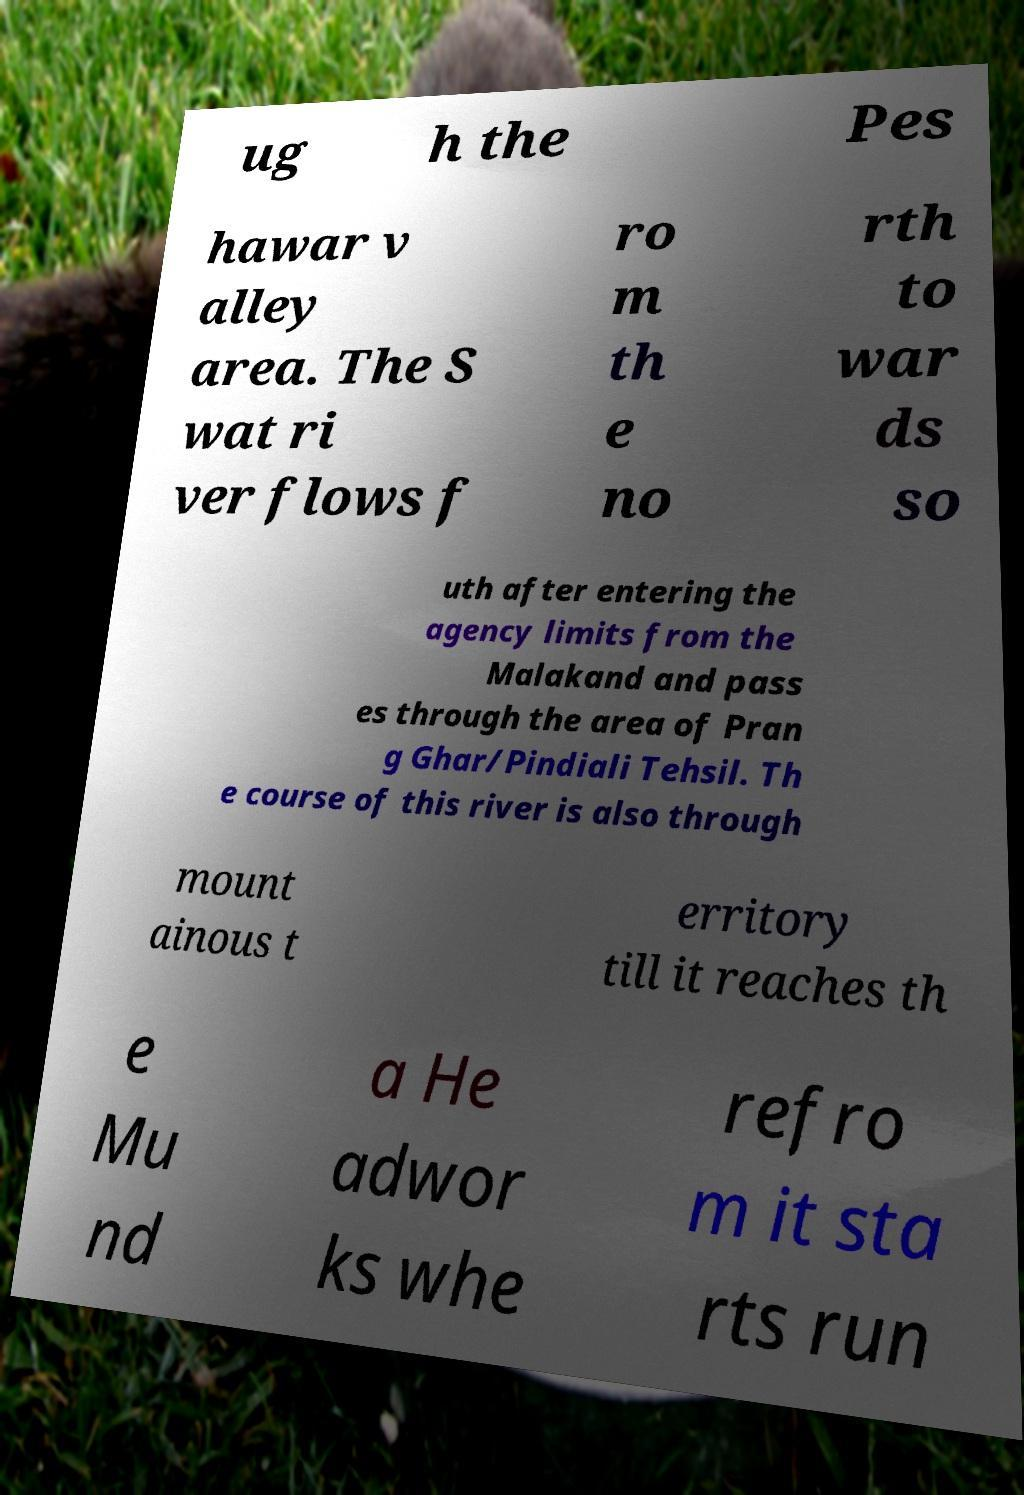There's text embedded in this image that I need extracted. Can you transcribe it verbatim? ug h the Pes hawar v alley area. The S wat ri ver flows f ro m th e no rth to war ds so uth after entering the agency limits from the Malakand and pass es through the area of Pran g Ghar/Pindiali Tehsil. Th e course of this river is also through mount ainous t erritory till it reaches th e Mu nd a He adwor ks whe refro m it sta rts run 